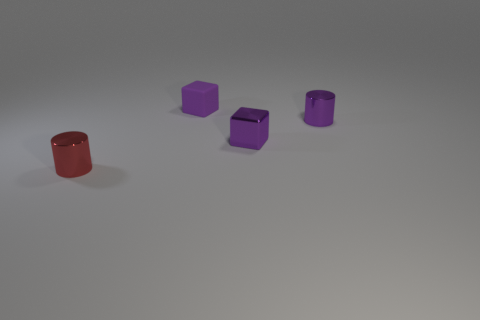Add 3 cylinders. How many objects exist? 7 Add 4 big brown balls. How many big brown balls exist? 4 Subtract 0 blue cubes. How many objects are left? 4 Subtract all cubes. Subtract all purple cubes. How many objects are left? 0 Add 4 purple matte cubes. How many purple matte cubes are left? 5 